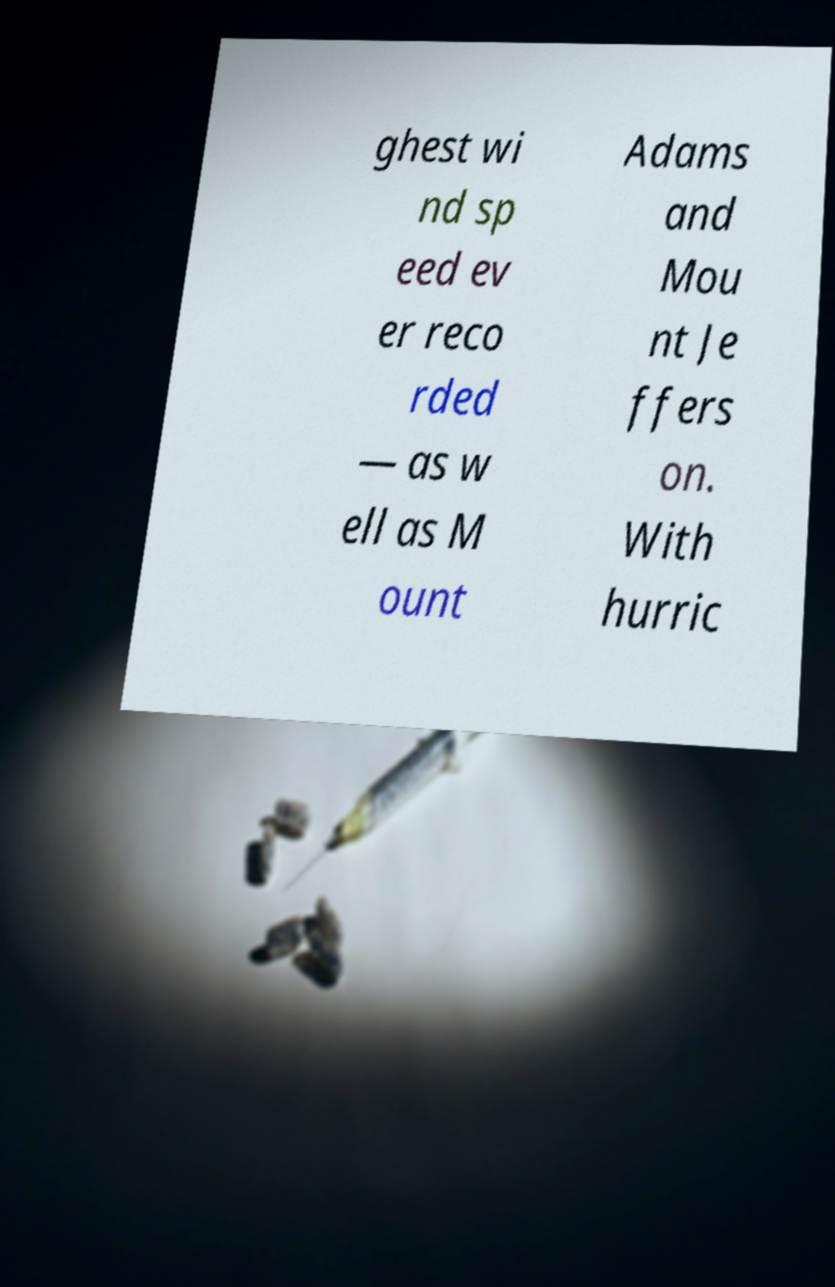There's text embedded in this image that I need extracted. Can you transcribe it verbatim? ghest wi nd sp eed ev er reco rded — as w ell as M ount Adams and Mou nt Je ffers on. With hurric 